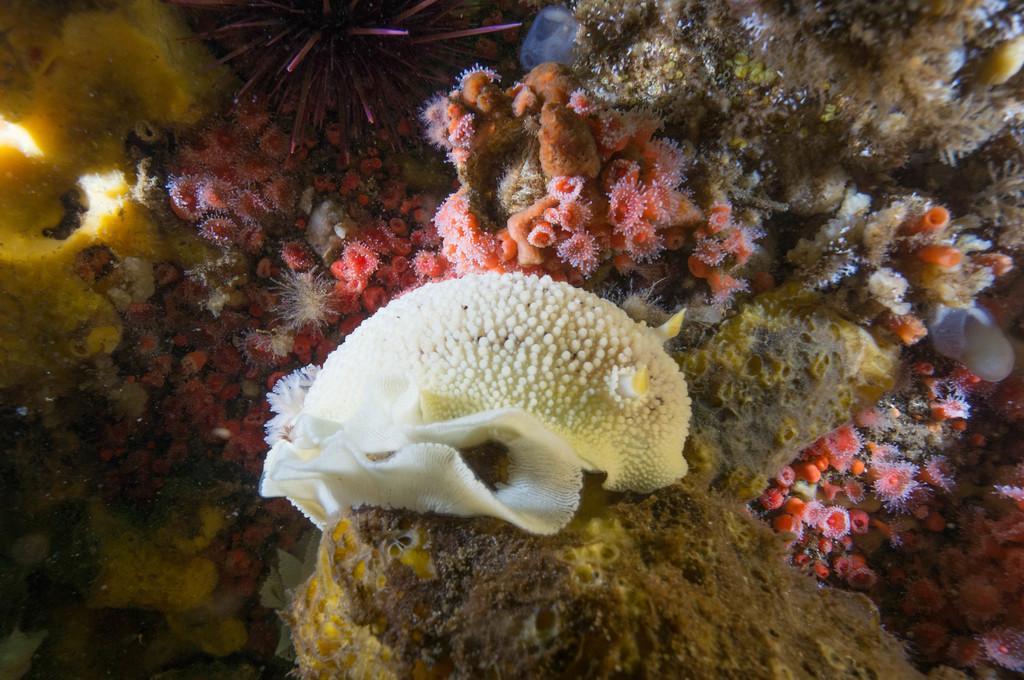What type of environment is shown in the image? The image depicts an underwater environment. What time of day is it in the underwater environment shown in the image? The time of day cannot be determined from the image, as it does not provide any information about the time. Can you see a ladybug swimming in the underwater environment in the image? There is no ladybug present in the image, as it only depicts an underwater environment. 